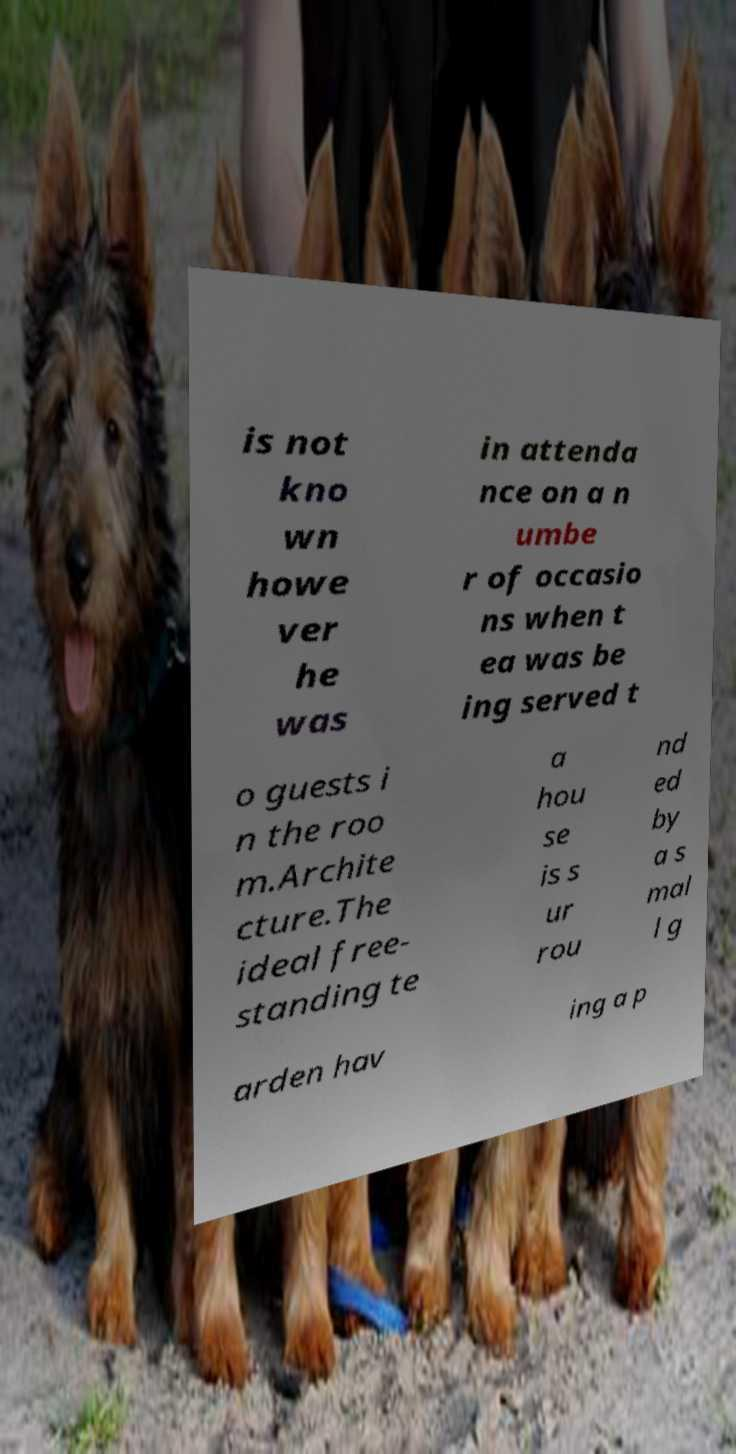What messages or text are displayed in this image? I need them in a readable, typed format. is not kno wn howe ver he was in attenda nce on a n umbe r of occasio ns when t ea was be ing served t o guests i n the roo m.Archite cture.The ideal free- standing te a hou se is s ur rou nd ed by a s mal l g arden hav ing a p 